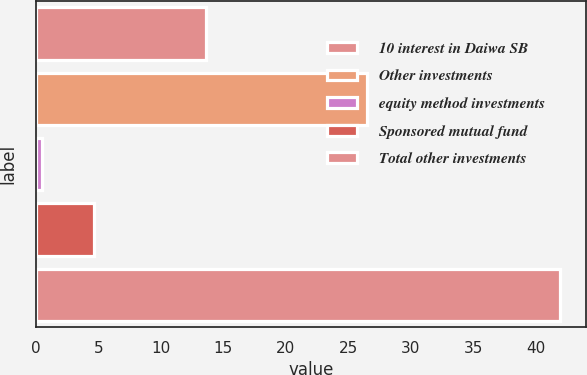Convert chart. <chart><loc_0><loc_0><loc_500><loc_500><bar_chart><fcel>10 interest in Daiwa SB<fcel>Other investments<fcel>equity method investments<fcel>Sponsored mutual fund<fcel>Total other investments<nl><fcel>13.6<fcel>26.5<fcel>0.5<fcel>4.64<fcel>41.9<nl></chart> 